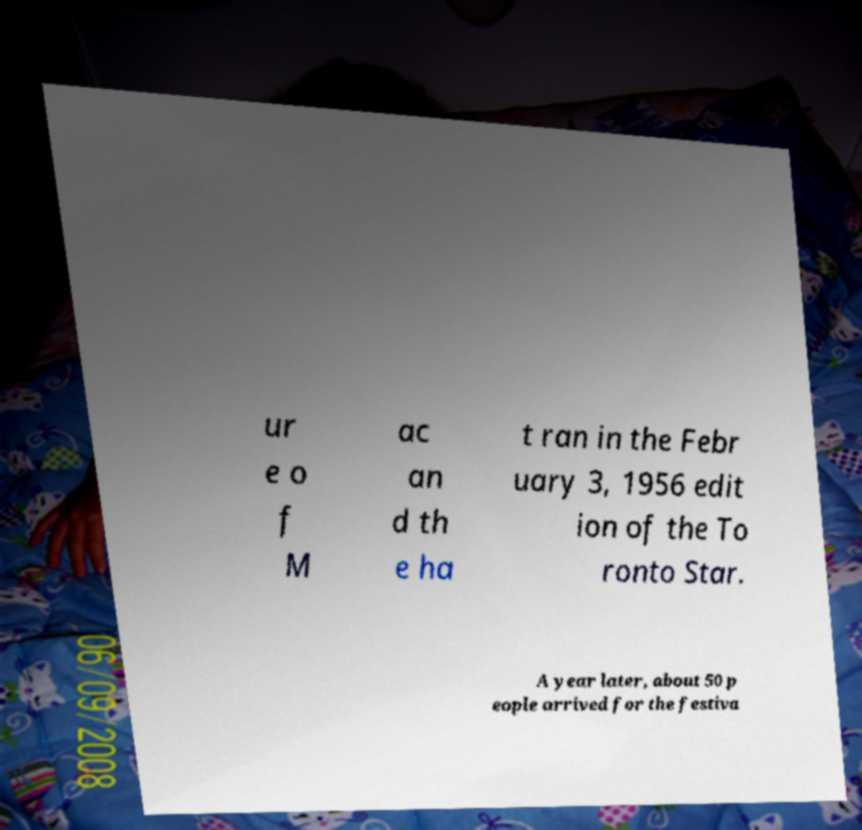For documentation purposes, I need the text within this image transcribed. Could you provide that? ur e o f M ac an d th e ha t ran in the Febr uary 3, 1956 edit ion of the To ronto Star. A year later, about 50 p eople arrived for the festiva 